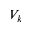Convert formula to latex. <formula><loc_0><loc_0><loc_500><loc_500>V _ { k }</formula> 